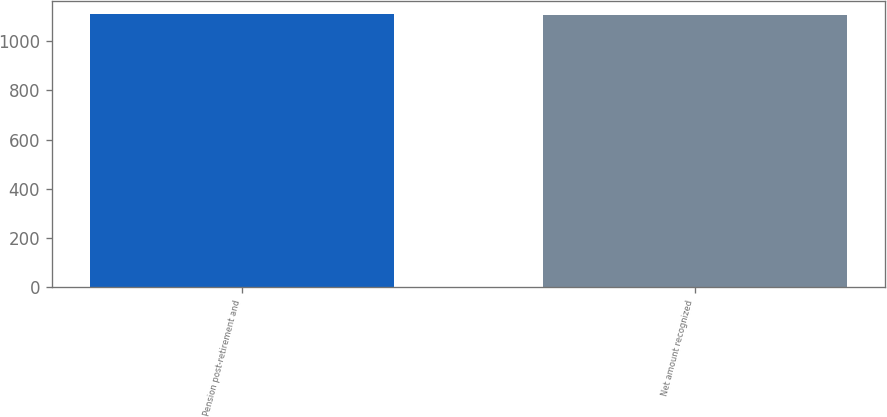Convert chart to OTSL. <chart><loc_0><loc_0><loc_500><loc_500><bar_chart><fcel>Pension post-retirement and<fcel>Net amount recognized<nl><fcel>1110<fcel>1106<nl></chart> 